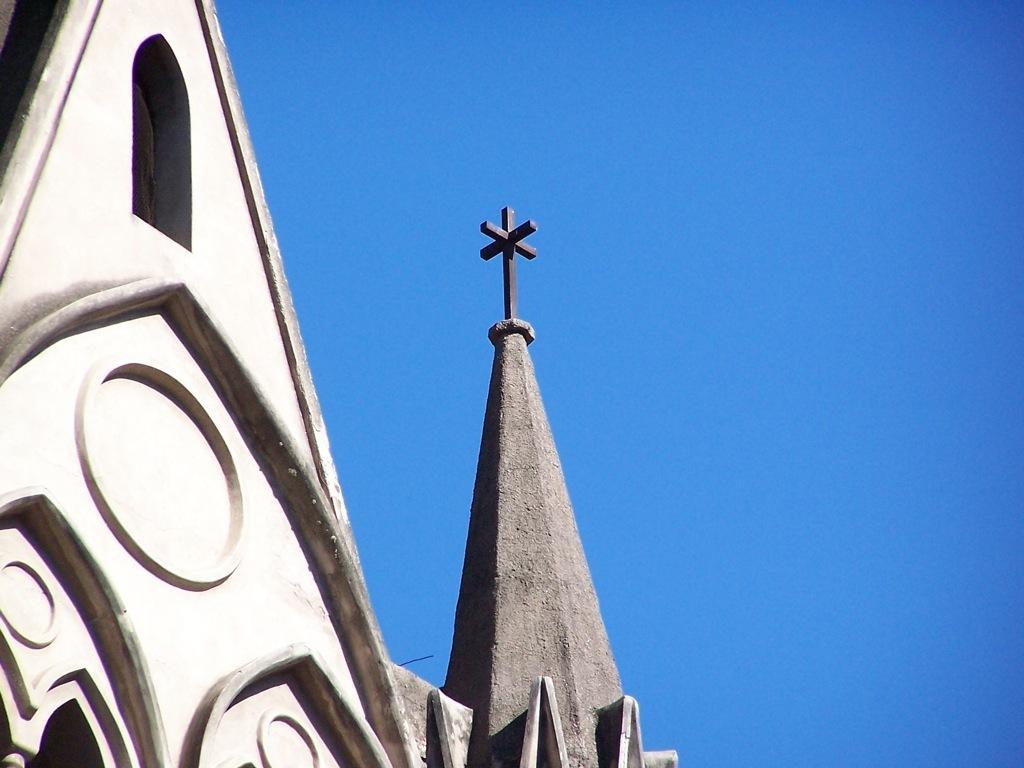Please provide a concise description of this image. In the foreground of the image there is a building. In the background of the image there is sky. 